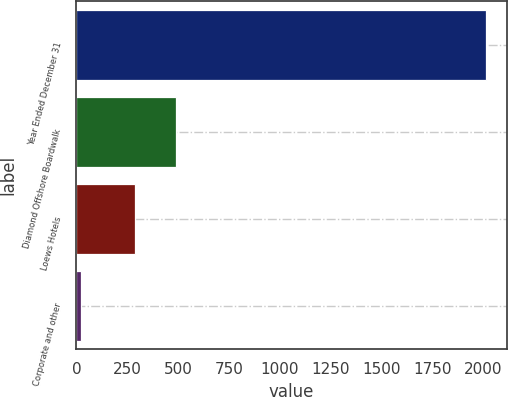<chart> <loc_0><loc_0><loc_500><loc_500><bar_chart><fcel>Year Ended December 31<fcel>Diamond Offshore Boardwalk<fcel>Loews Hotels<fcel>Corporate and other<nl><fcel>2014<fcel>488<fcel>289<fcel>24<nl></chart> 